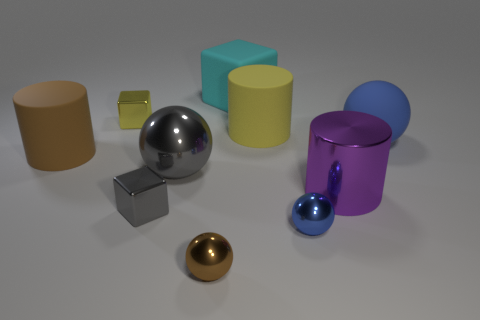Subtract all cyan balls. Subtract all yellow cylinders. How many balls are left? 4 Subtract all cubes. How many objects are left? 7 Add 7 big brown things. How many big brown things are left? 8 Add 2 small blue things. How many small blue things exist? 3 Subtract 1 purple cylinders. How many objects are left? 9 Subtract all yellow rubber things. Subtract all yellow rubber objects. How many objects are left? 8 